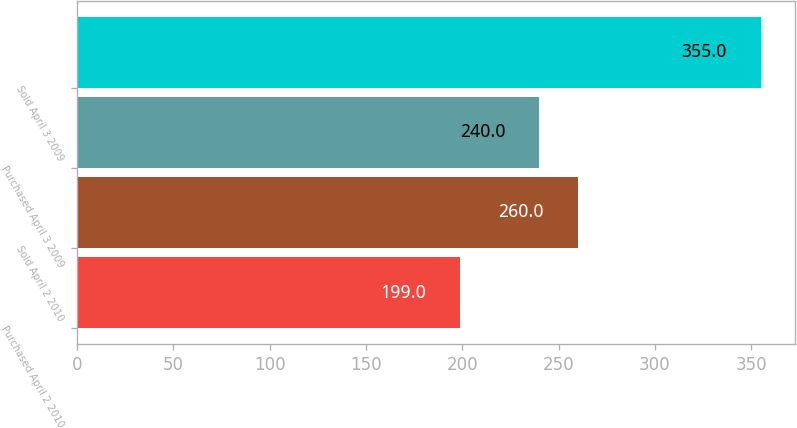Convert chart to OTSL. <chart><loc_0><loc_0><loc_500><loc_500><bar_chart><fcel>Purchased April 2 2010<fcel>Sold April 2 2010<fcel>Purchased April 3 2009<fcel>Sold April 3 2009<nl><fcel>199<fcel>260<fcel>240<fcel>355<nl></chart> 